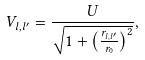Convert formula to latex. <formula><loc_0><loc_0><loc_500><loc_500>V _ { l , l ^ { \prime } } = \frac { U } { \sqrt { 1 + \left ( \frac { r _ { l , l ^ { \prime } } } { r _ { 0 } } \right ) ^ { 2 } } } ,</formula> 